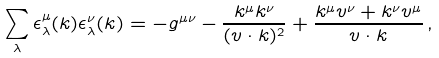<formula> <loc_0><loc_0><loc_500><loc_500>\sum _ { \lambda } \epsilon _ { \lambda } ^ { \mu } ( k ) \epsilon _ { \lambda } ^ { \nu } ( k ) = - g ^ { \mu \nu } - \frac { k ^ { \mu } k ^ { \nu } } { ( v \cdot k ) ^ { 2 } } + \frac { k ^ { \mu } v ^ { \nu } + k ^ { \nu } v ^ { \mu } } { v \cdot k } \, ,</formula> 